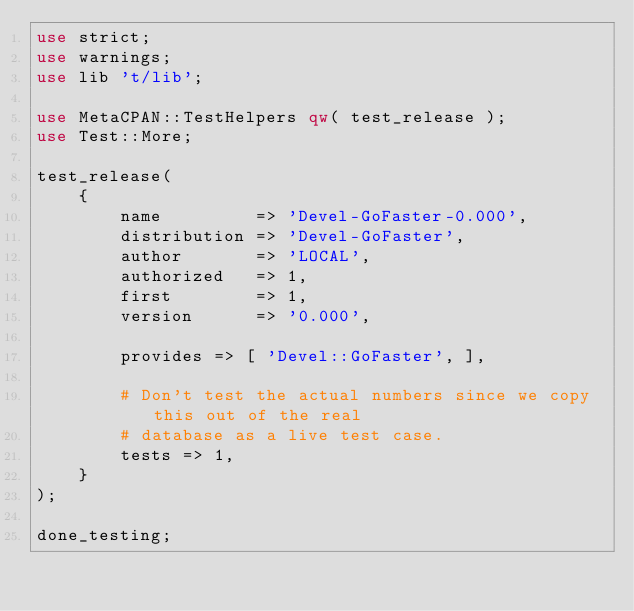Convert code to text. <code><loc_0><loc_0><loc_500><loc_500><_Perl_>use strict;
use warnings;
use lib 't/lib';

use MetaCPAN::TestHelpers qw( test_release );
use Test::More;

test_release(
    {
        name         => 'Devel-GoFaster-0.000',
        distribution => 'Devel-GoFaster',
        author       => 'LOCAL',
        authorized   => 1,
        first        => 1,
        version      => '0.000',

        provides => [ 'Devel::GoFaster', ],

        # Don't test the actual numbers since we copy this out of the real
        # database as a live test case.
        tests => 1,
    }
);

done_testing;
</code> 